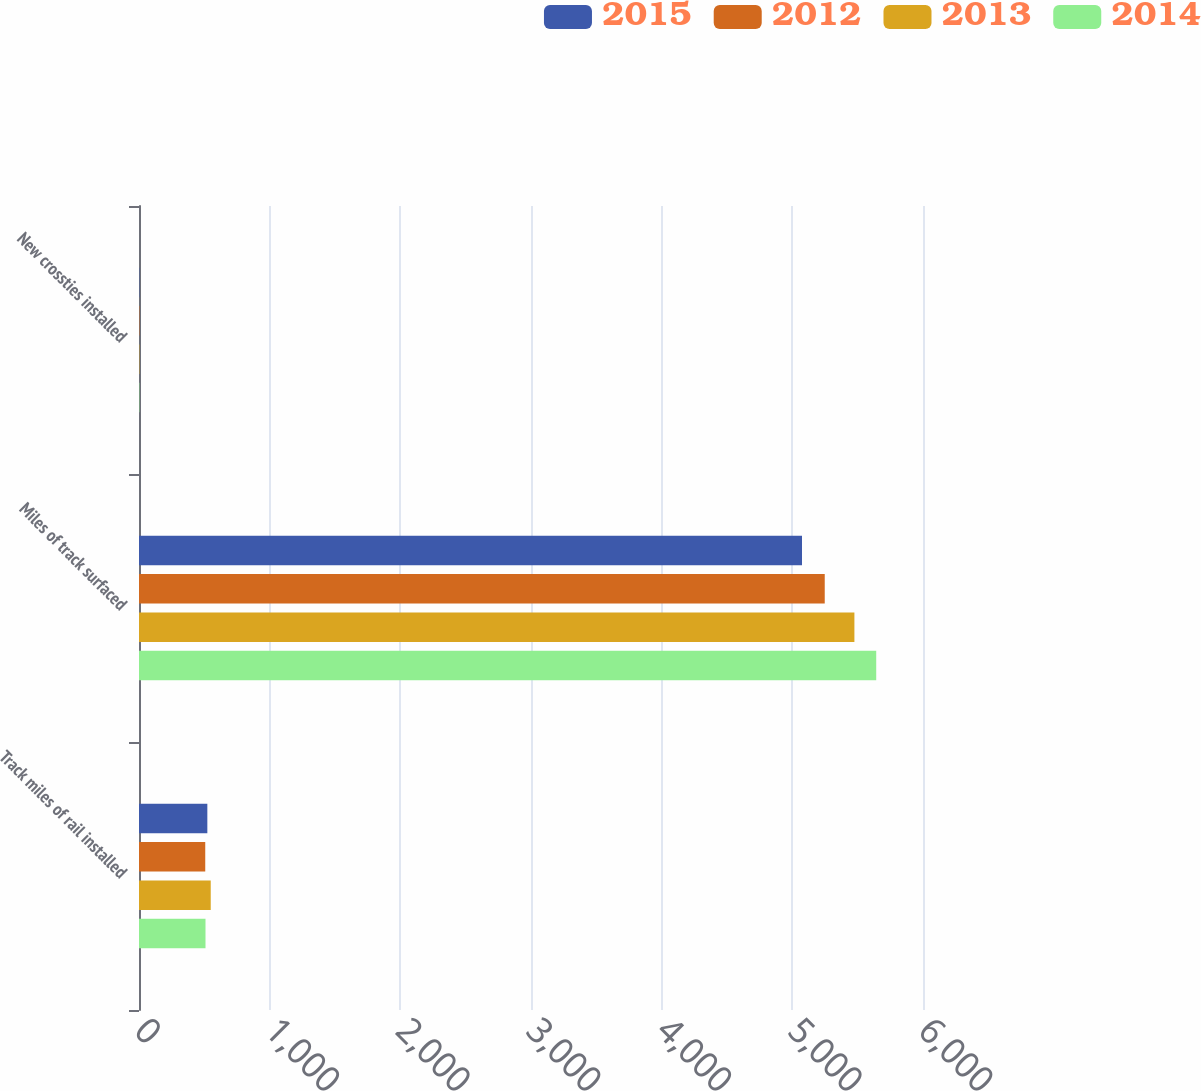Convert chart. <chart><loc_0><loc_0><loc_500><loc_500><stacked_bar_chart><ecel><fcel>Track miles of rail installed<fcel>Miles of track surfaced<fcel>New crossties installed<nl><fcel>2015<fcel>523<fcel>5074<fcel>2.4<nl><fcel>2012<fcel>507<fcel>5248<fcel>2.7<nl><fcel>2013<fcel>549<fcel>5475<fcel>2.5<nl><fcel>2014<fcel>509<fcel>5642<fcel>2.6<nl></chart> 